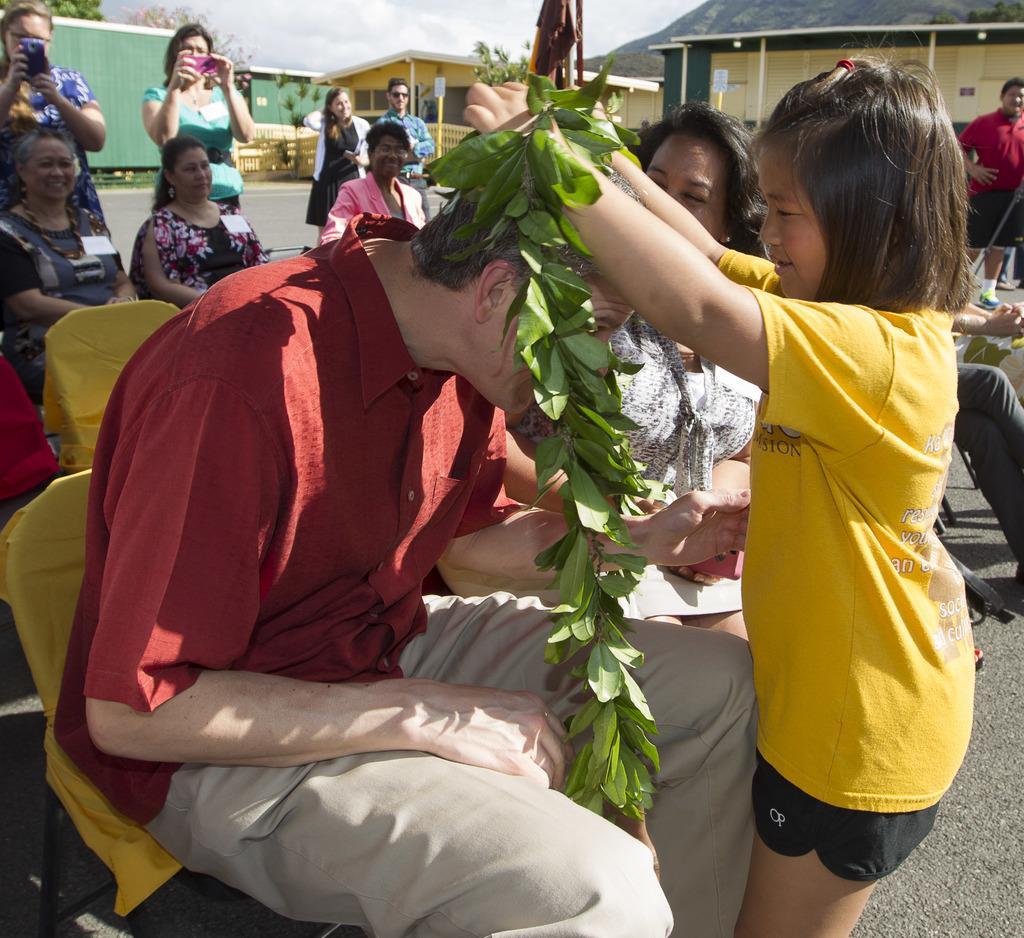Could you give a brief overview of what you see in this image? Here I can see a girl is giving garland of leaves to a man who is sitting on the chair. At the back of these people many people are sitting on the chairs and looking at this man. In the background few people are standing and holding mobiles in the hands and also I can see few buildings. At the top of the image I can see the sky. 